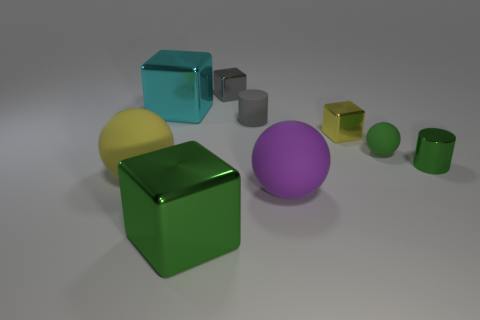Add 1 big green things. How many objects exist? 10 Subtract all blocks. How many objects are left? 5 Subtract 0 brown blocks. How many objects are left? 9 Subtract all small cyan metallic cylinders. Subtract all big metallic blocks. How many objects are left? 7 Add 6 big yellow balls. How many big yellow balls are left? 7 Add 9 gray rubber cylinders. How many gray rubber cylinders exist? 10 